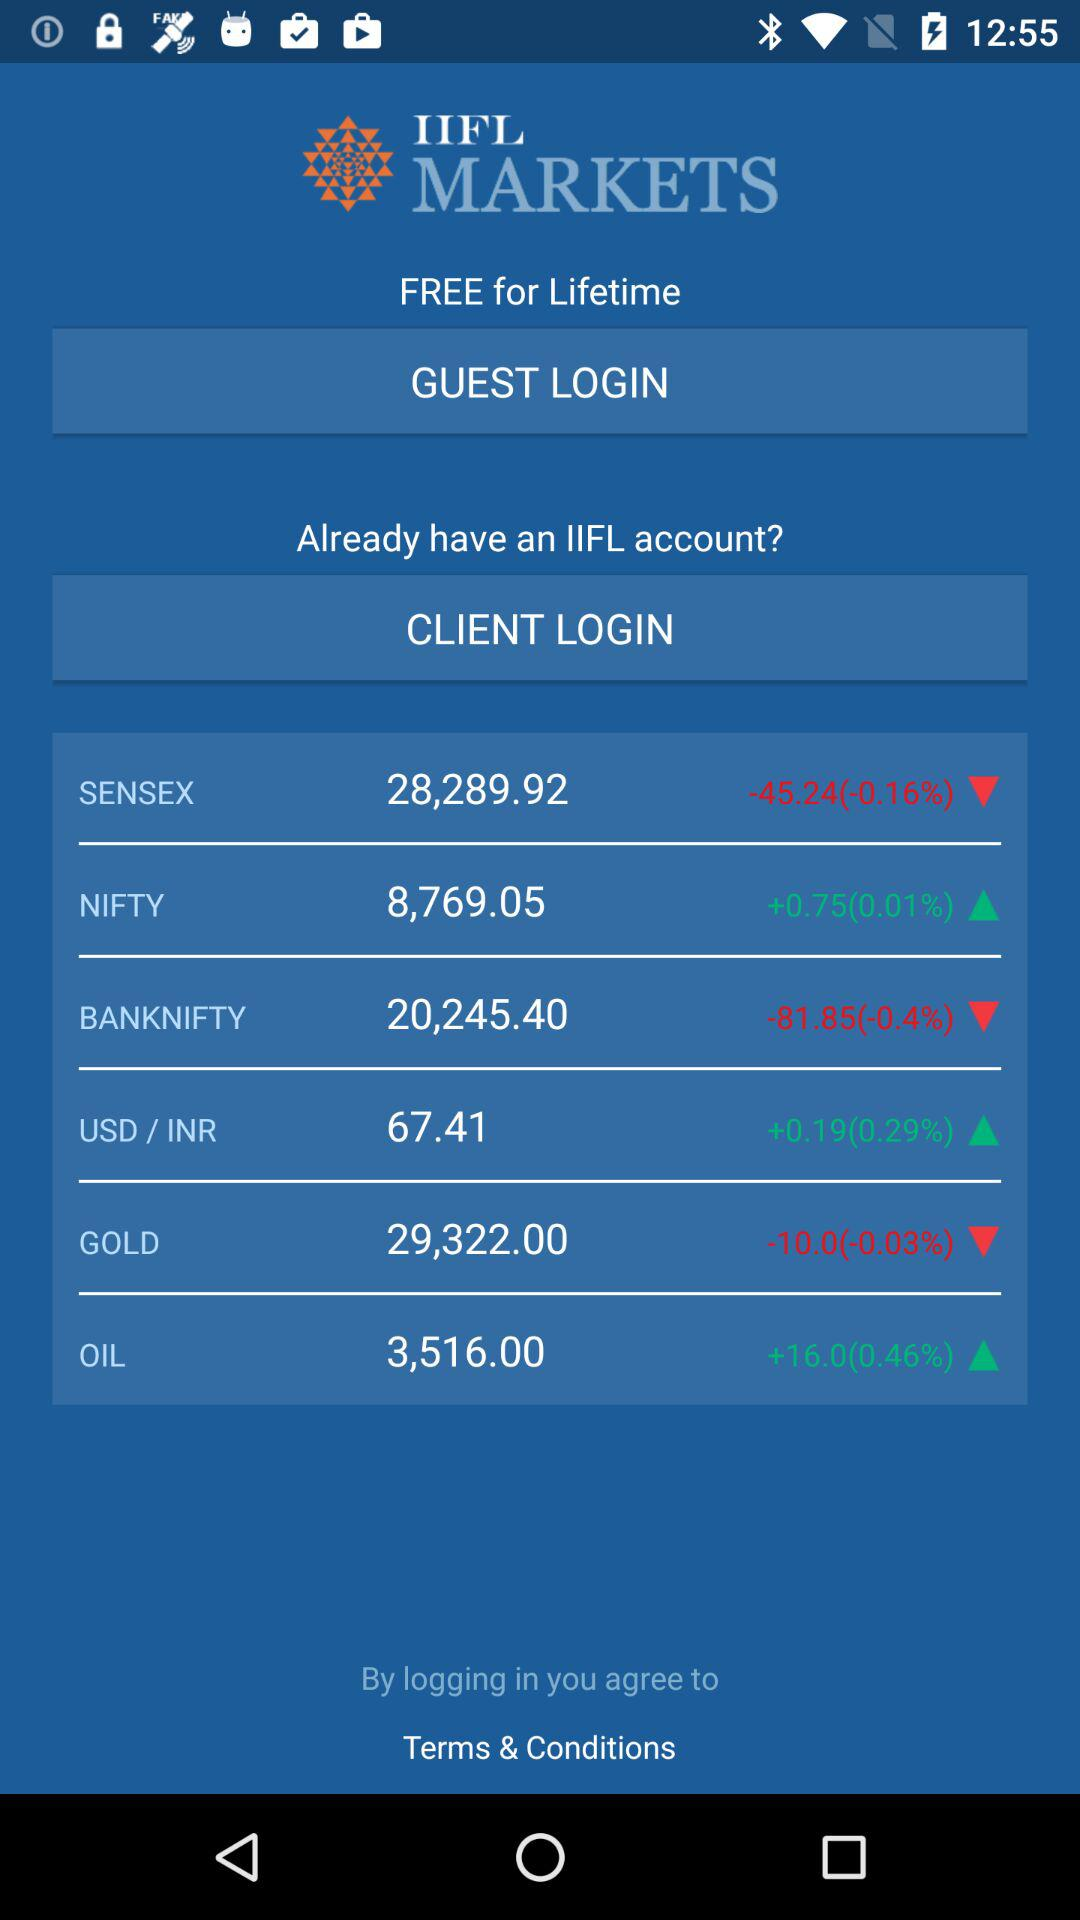What is the percentage change in Sensex stock? The percentage change in Sensex stock is -0.16%. 